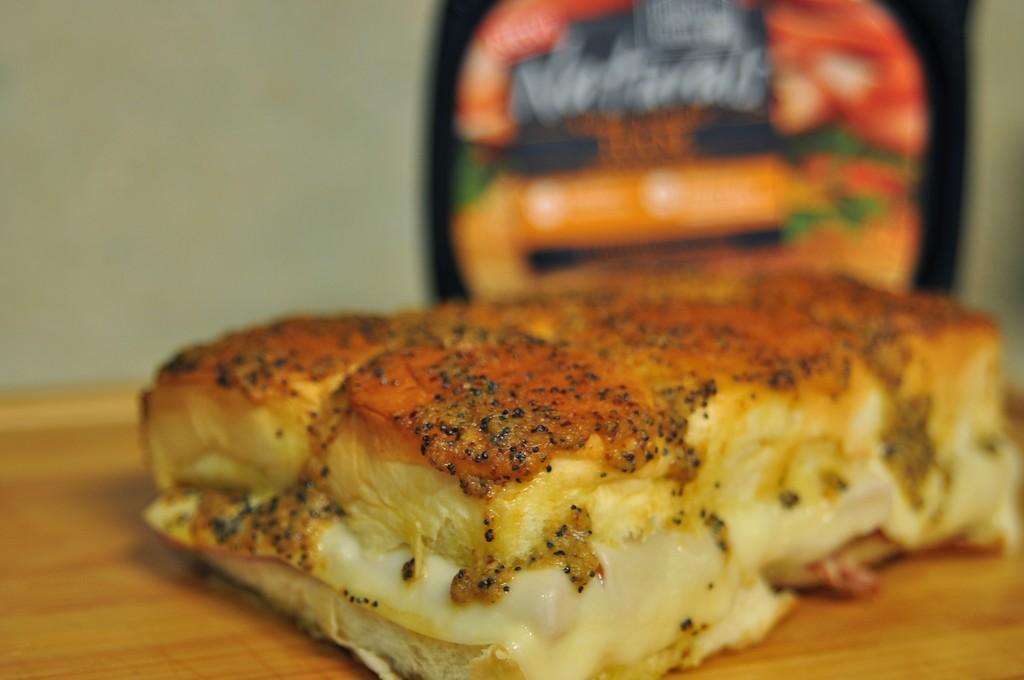Describe this image in one or two sentences. In the center of the image we can see one table. On the table, we can see some food item. In the background there is a wall and a banner. 